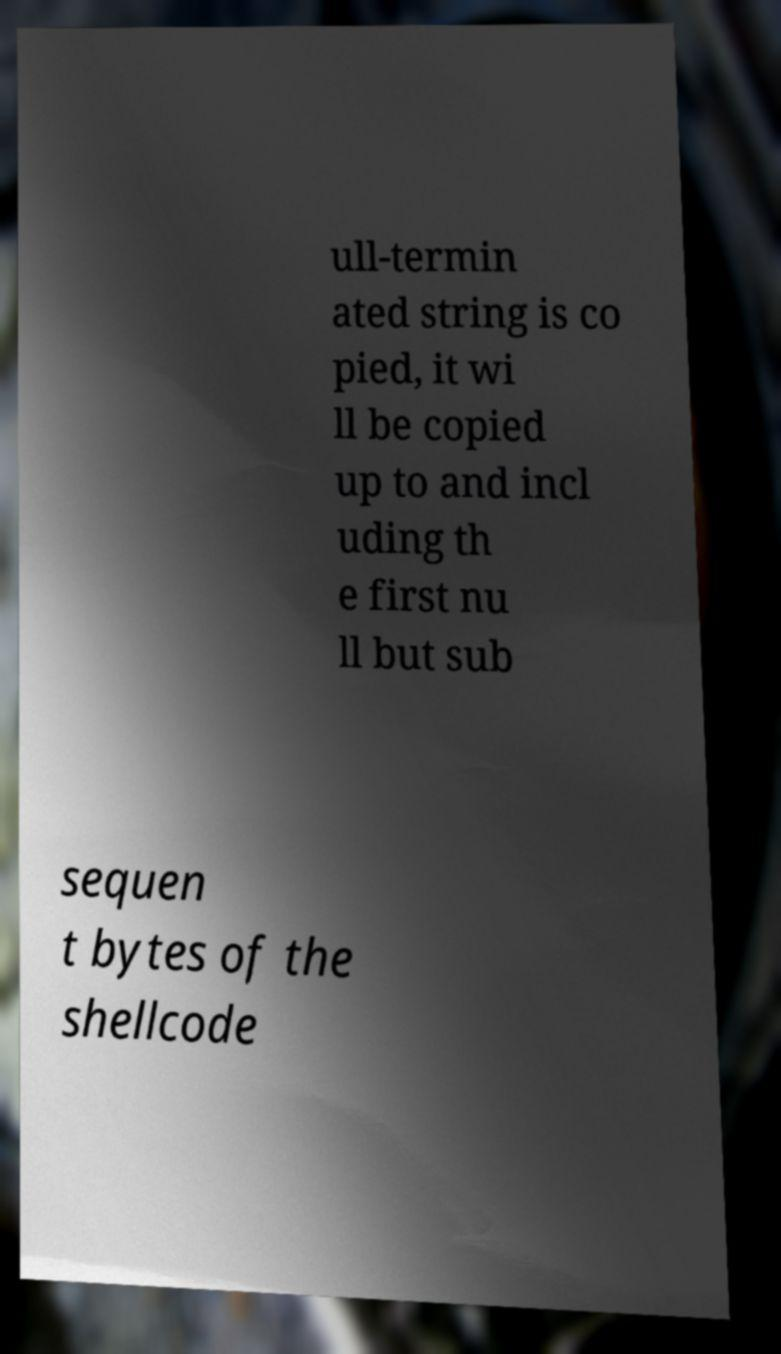There's text embedded in this image that I need extracted. Can you transcribe it verbatim? ull-termin ated string is co pied, it wi ll be copied up to and incl uding th e first nu ll but sub sequen t bytes of the shellcode 